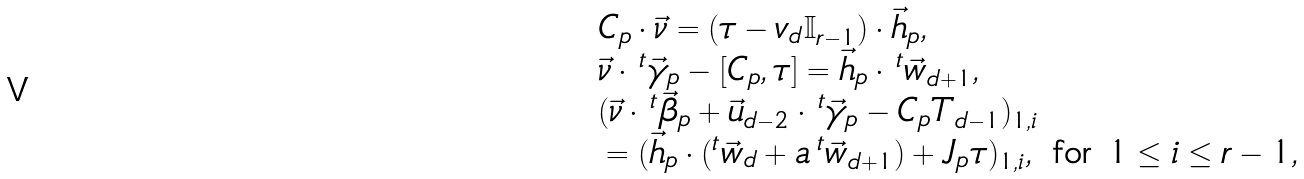Convert formula to latex. <formula><loc_0><loc_0><loc_500><loc_500>& C _ { p } \cdot \vec { \nu } = ( \tau - v _ { d } \mathbb { I } _ { r - 1 } ) \cdot \vec { h } _ { p } , \\ & \vec { \nu } \cdot \, ^ { t } \vec { \gamma } _ { p } - [ C _ { p } , \tau ] = \vec { h } _ { p } \cdot \, ^ { t } \vec { w } _ { d + 1 } , \\ & ( \vec { \nu } \cdot \, ^ { t } \vec { \beta } _ { p } + \vec { u } _ { d - 2 } \cdot \, ^ { t } \vec { \gamma } _ { p } - C _ { p } T _ { d - 1 } ) _ { 1 , i } \\ & = ( \vec { h } _ { p } \cdot ( ^ { t } \vec { w } _ { d } + a \, ^ { t } \vec { w } _ { d + 1 } ) + J _ { p } \tau ) _ { 1 , i } , \text { for $1 \leq i \leq r-1$} ,</formula> 